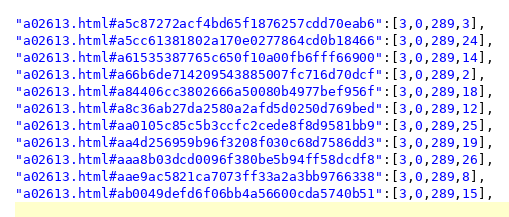Convert code to text. <code><loc_0><loc_0><loc_500><loc_500><_JavaScript_>"a02613.html#a5c87272acf4bd65f1876257cdd70eab6":[3,0,289,3],
"a02613.html#a5cc61381802a170e0277864cd0b18466":[3,0,289,24],
"a02613.html#a61535387765c650f10a00fb6fff66900":[3,0,289,14],
"a02613.html#a66b6de714209543885007fc716d70dcf":[3,0,289,2],
"a02613.html#a84406cc3802666a50080b4977bef956f":[3,0,289,18],
"a02613.html#a8c36ab27da2580a2afd5d0250d769bed":[3,0,289,12],
"a02613.html#aa0105c85c5b3ccfc2cede8f8d9581bb9":[3,0,289,25],
"a02613.html#aa4d256959b96f3208f030c68d7586dd3":[3,0,289,19],
"a02613.html#aaa8b03dcd0096f380be5b94ff58dcdf8":[3,0,289,26],
"a02613.html#aae9ac5821ca7073ff33a2a3bb9766338":[3,0,289,8],
"a02613.html#ab0049defd6f06bb4a56600cda5740b51":[3,0,289,15],</code> 